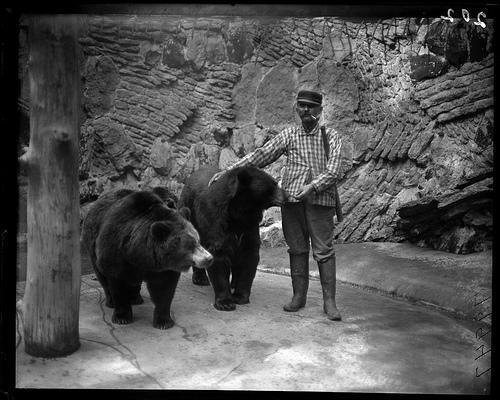How many people are in this picture?
Give a very brief answer. 1. How many bears are in the photo?
Give a very brief answer. 2. 